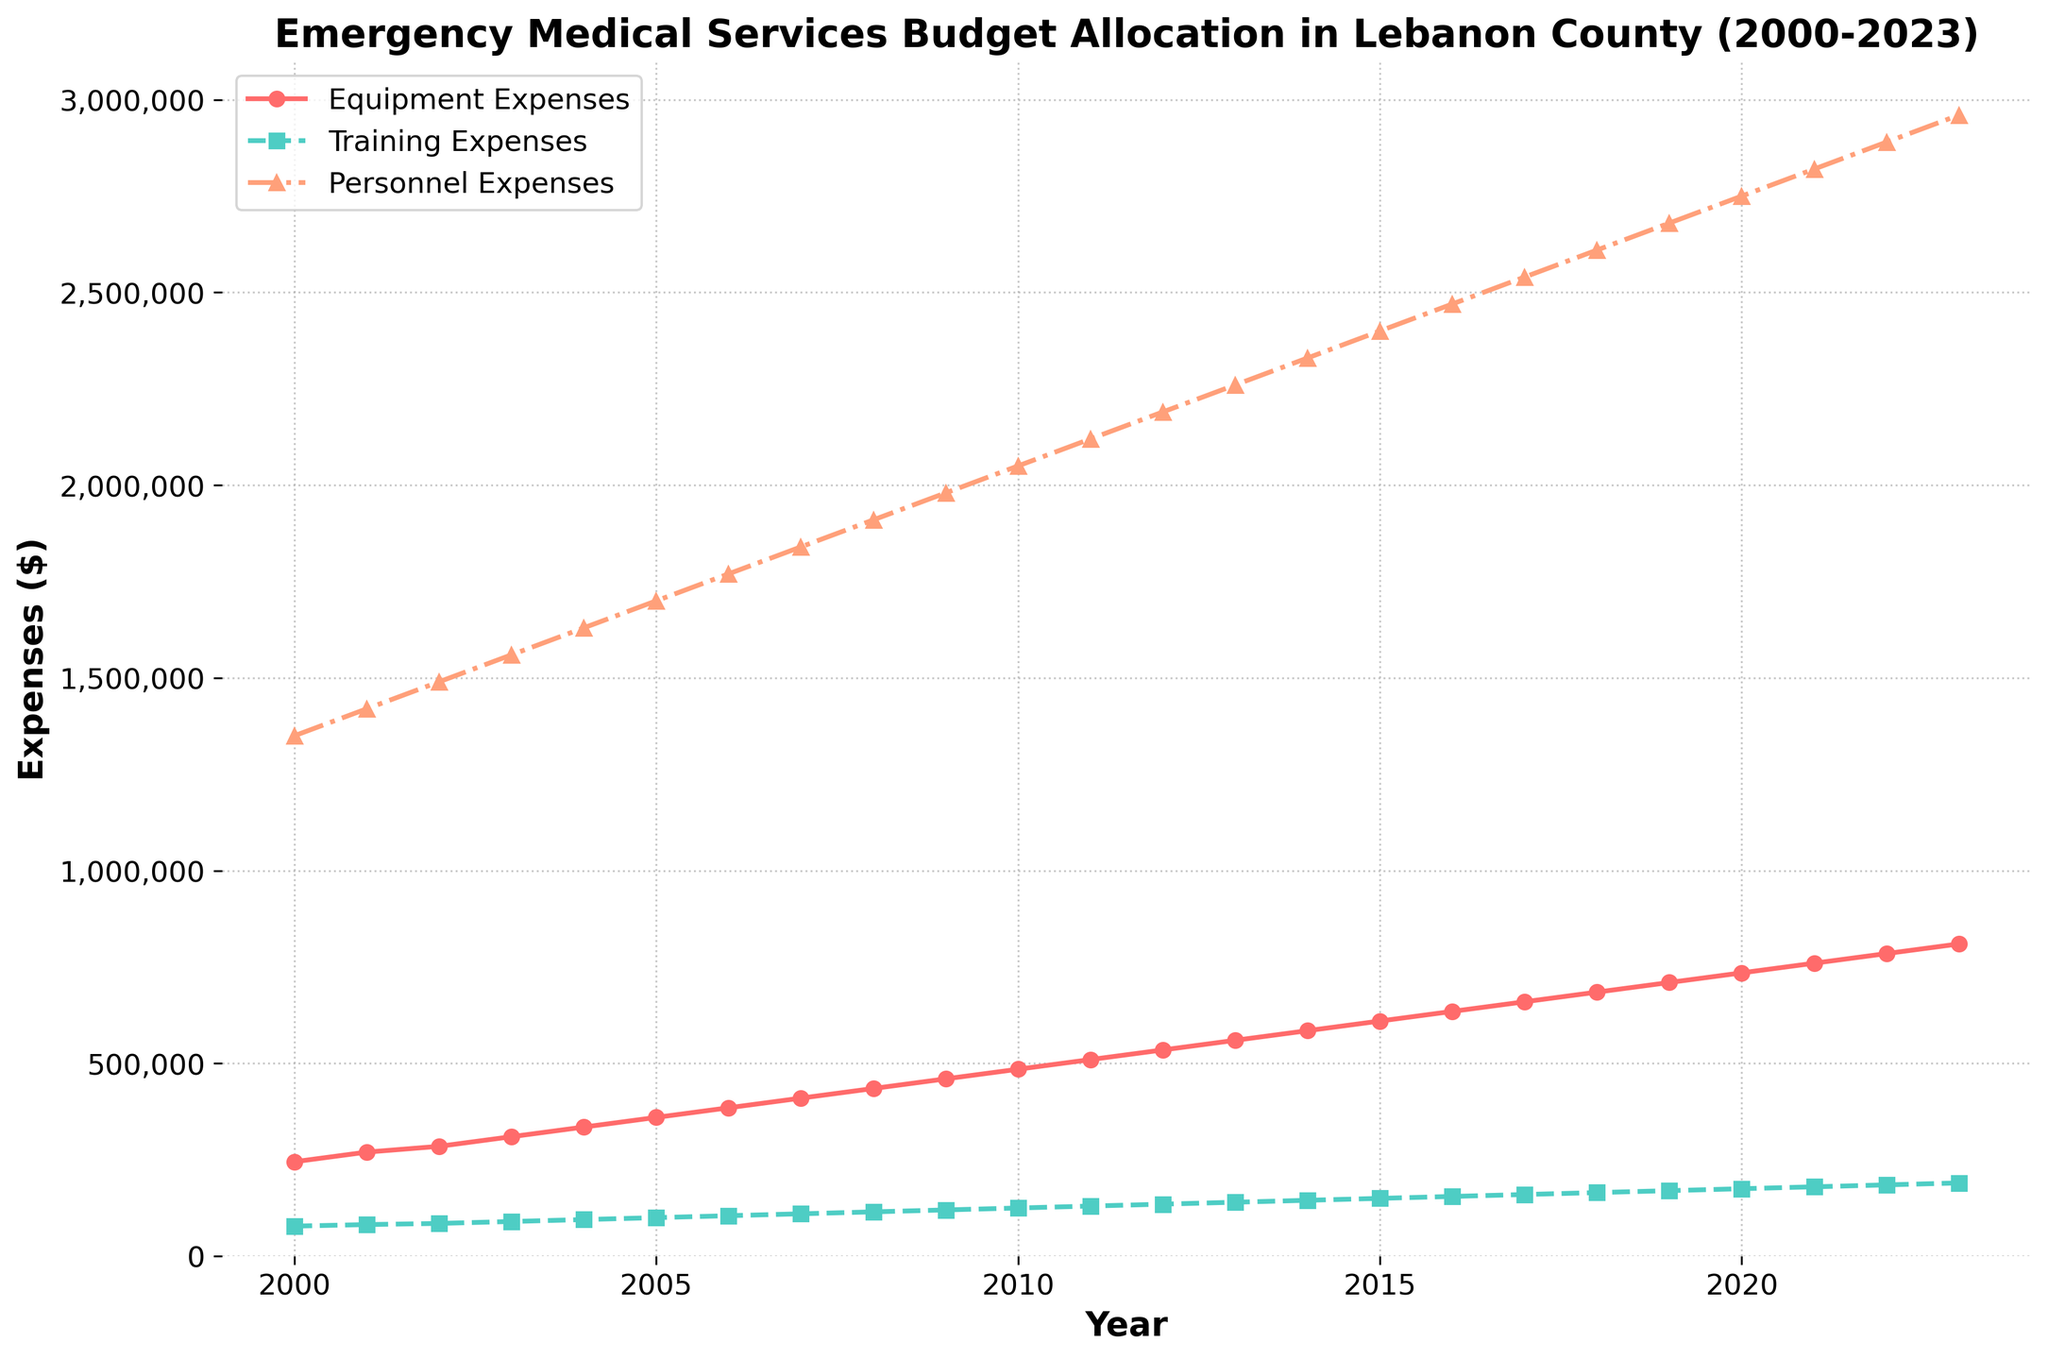How much did the personnel expenses increase from 2000 to 2023? To determine the increase, subtract the personnel expenses in 2000 from the personnel expenses in 2023: 2,960,000 - 1,350,000
Answer: 1,610,000 Which category had the highest expenses in 2023? By observing the endpoints of each line in the figure, the personnel expenses line reaches the highest value at 2,960,000 in 2023.
Answer: Personnel expenses What was the average equipment expense over the period 2000-2023? Sum all equipment expenses from 2000 to 2023 and divide by the number of years: (245,000 + 270,000 + 285,000 + 310,000 + 335,000 + 360,000 + 385,000 + 410,000 + 435,000 + 460,000 + 485,000 + 510,000 + 535,000 + 560,000 + 585,000 + 610,000 + 635,000 + 660,000 + 685,000 + 710,000 + 735,000 + 760,000 + 785,000 + 810,000) / 24
Answer: 530,000 How much more was spent on equipment than training in 2010? Subtract the training expenses from the equipment expenses in 2010: 485,000 - 125,000
Answer: 360,000 Between which years did training expenses have the highest rate of increase? To find the highest rate of increase, compare the year-over-year changes in training expenses and determine the largest change: 2012 to 2013 has the largest increase (140,000 - 135,000 = 5,000). No other change exceeds this amount.
Answer: 2012 to 2013 By how much did the total expenses (sum of equipment, training, and personnel expenses) increase from 2005 to 2015? First, calculate the total expenses for 2005 and 2015, then find the difference: Total expenses 2005 = 360,000 + 100,000 + 1,700,000 = 2,160,000 and Total expenses 2015 = 610,000 + 150,000 + 2,400,000 = 3,160,000. The increase is 3,160,000 - 2,160,000
Answer: 1,000,000 Which expense category experienced the most consistent annual increase over the years? By examining the slopes of the lines, the personnel expenses line shows a relatively steady and consistent increase each year without large fluctuations.
Answer: Personnel expenses How many years did it take for equipment expenses to double from the expense in 2000? Determine when the equipment expenses reached twice the value of 2000 (490,000): The expense doubled in 2010 (485,000 is closest but not reaching exactly double until 2011).
Answer: 10-11 years When did all three expense categories exceed 500,000 for the first time? By observing the figure, in the year 2011, both equipment and personnel expenses were already over 500,000, and the training expense reached exactly 500,000.
Answer: 2011 